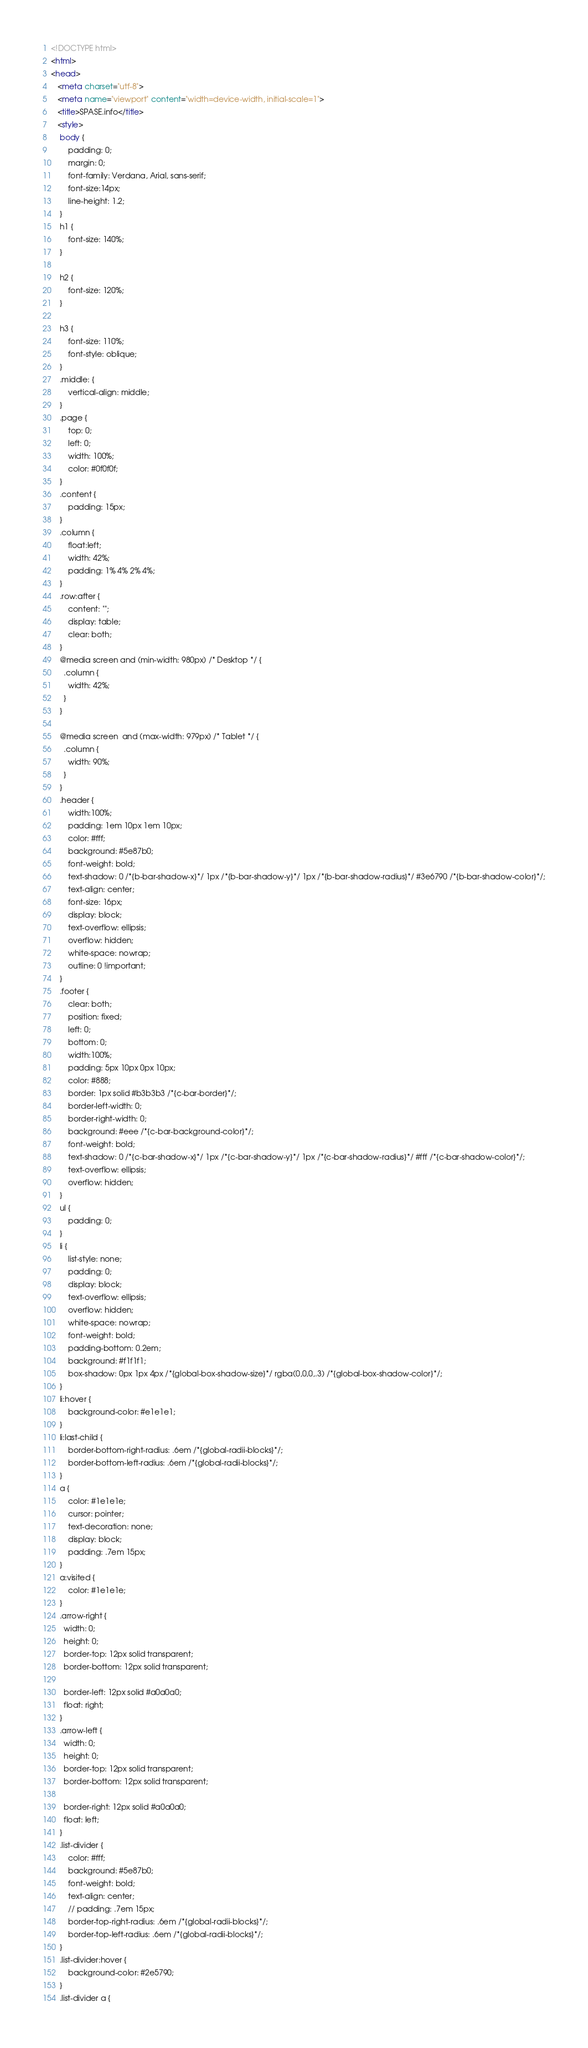Convert code to text. <code><loc_0><loc_0><loc_500><loc_500><_HTML_><!DOCTYPE html>
<html>
<head>
   <meta charset="utf-8">
   <meta name="viewport" content="width=device-width, initial-scale=1">
   <title>SPASE.info</title>
   <style>
	body {
		padding: 0;
		margin: 0;
		font-family: Verdana, Arial, sans-serif; 
		font-size:14px; 
		line-height: 1.2;
	}
	h1 {
		font-size: 140%;
	}

	h2 {
		font-size: 120%;
	}

	h3 {
		font-size: 110%;
		font-style: oblique;
	}
	.middle: {
		vertical-align: middle;
	}
	.page {
		top: 0;
		left: 0;
		width: 100%;
		color: #0f0f0f;
	}
	.content {
		padding: 15px;
	}
	.column {
		float:left;
		width: 42%;
		padding: 1% 4% 2% 4%;
	}
	.row:after {
		content: "";
		display: table;
		clear: both;
	}	
	@media screen and (min-width: 980px) /* Desktop */ {
	  .column {
		width: 42%;
	  }
	}

	@media screen  and (max-width: 979px) /* Tablet */ {
	  .column {
		width: 90%;
	  }
	}
	.header {
		width:100%;
		padding: 1em 10px 1em 10px;
		color: #fff;
		background: #5e87b0;
		font-weight: bold;
		text-shadow: 0 /*{b-bar-shadow-x}*/ 1px /*{b-bar-shadow-y}*/ 1px /*{b-bar-shadow-radius}*/ #3e6790 /*{b-bar-shadow-color}*/;
		text-align: center;
		font-size: 16px;
		display: block;
		text-overflow: ellipsis;
		overflow: hidden;
		white-space: nowrap;
		outline: 0 !important;
	}
	.footer {
		clear: both;
		position: fixed;
		left: 0;
		bottom: 0;
		width:100%;
		padding: 5px 10px 0px 10px;
		color: #888;
		border: 1px solid #b3b3b3 /*{c-bar-border}*/;
		border-left-width: 0;
		border-right-width: 0;
		background: #eee /*{c-bar-background-color}*/;
		font-weight: bold;
		text-shadow: 0 /*{c-bar-shadow-x}*/ 1px /*{c-bar-shadow-y}*/ 1px /*{c-bar-shadow-radius}*/ #fff /*{c-bar-shadow-color}*/;
		text-overflow: ellipsis;
		overflow: hidden;
	}
	ul {
		padding: 0;
	}
	li {
		list-style: none;
		padding: 0;
		display: block;
	    text-overflow: ellipsis;
		overflow: hidden;
		white-space: nowrap;
		font-weight: bold;
		padding-bottom: 0.2em;
		background: #f1f1f1;
		box-shadow: 0px 1px 4px /*{global-box-shadow-size}*/ rgba(0,0,0,.3) /*{global-box-shadow-color}*/;
	}
	li:hover {
		background-color: #e1e1e1;
	}
	li:last-child {
		border-bottom-right-radius: .6em /*{global-radii-blocks}*/;
		border-bottom-left-radius: .6em /*{global-radii-blocks}*/;
	}
	a {
		color: #1e1e1e;
		cursor: pointer;
		text-decoration: none;
		display: block;
		padding: .7em 15px;
	}
	a:visited {
		color: #1e1e1e;
	}
	.arrow-right {
	  width: 0; 
	  height: 0; 
	  border-top: 12px solid transparent;
	  border-bottom: 12px solid transparent;
	  
	  border-left: 12px solid #a0a0a0;
	  float: right;
	}
	.arrow-left {
	  width: 0; 
	  height: 0; 
	  border-top: 12px solid transparent;
	  border-bottom: 12px solid transparent;
	  
	  border-right: 12px solid #a0a0a0;
	  float: left;
	}
	.list-divider {
		color: #fff;
		background: #5e87b0;
		font-weight: bold;
		text-align: center;
		// padding: .7em 15px;
		border-top-right-radius: .6em /*{global-radii-blocks}*/;
		border-top-left-radius: .6em /*{global-radii-blocks}*/;
	}
	.list-divider:hover {
		background-color: #2e5790;
	}
	.list-divider a {</code> 